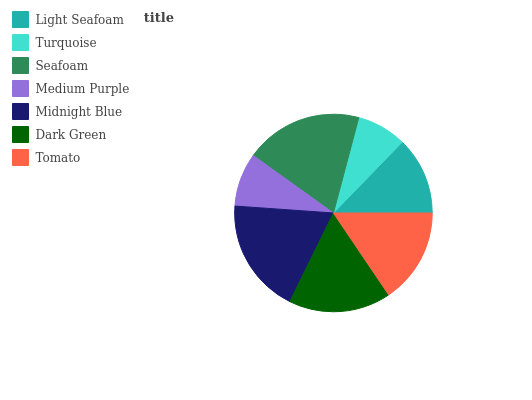Is Turquoise the minimum?
Answer yes or no. Yes. Is Seafoam the maximum?
Answer yes or no. Yes. Is Seafoam the minimum?
Answer yes or no. No. Is Turquoise the maximum?
Answer yes or no. No. Is Seafoam greater than Turquoise?
Answer yes or no. Yes. Is Turquoise less than Seafoam?
Answer yes or no. Yes. Is Turquoise greater than Seafoam?
Answer yes or no. No. Is Seafoam less than Turquoise?
Answer yes or no. No. Is Tomato the high median?
Answer yes or no. Yes. Is Tomato the low median?
Answer yes or no. Yes. Is Dark Green the high median?
Answer yes or no. No. Is Turquoise the low median?
Answer yes or no. No. 